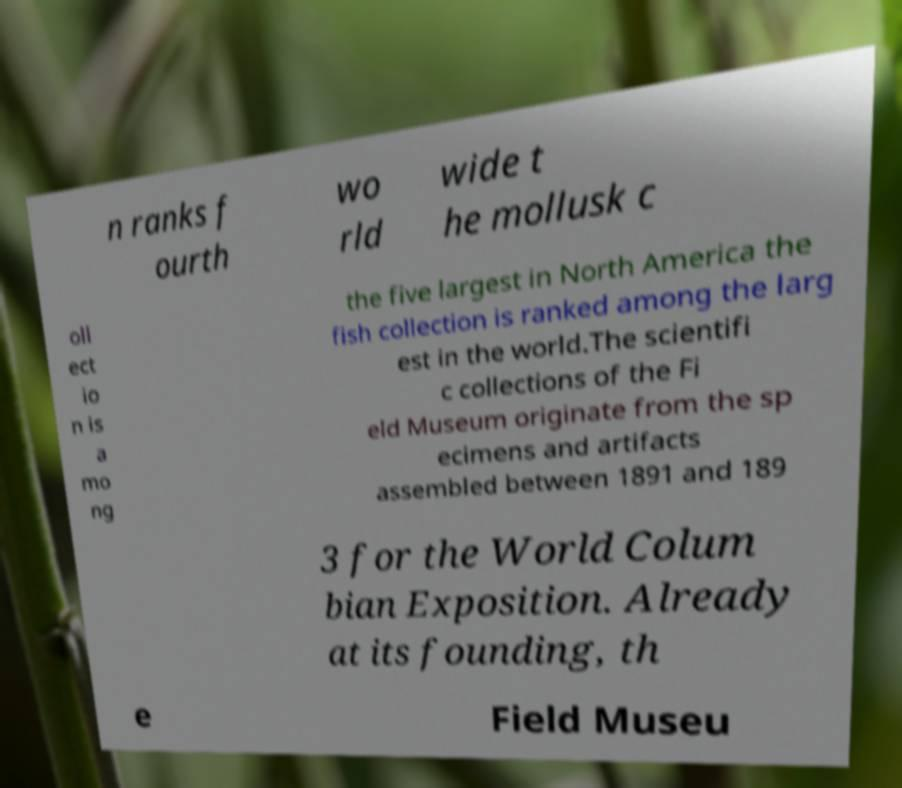Please read and relay the text visible in this image. What does it say? n ranks f ourth wo rld wide t he mollusk c oll ect io n is a mo ng the five largest in North America the fish collection is ranked among the larg est in the world.The scientifi c collections of the Fi eld Museum originate from the sp ecimens and artifacts assembled between 1891 and 189 3 for the World Colum bian Exposition. Already at its founding, th e Field Museu 